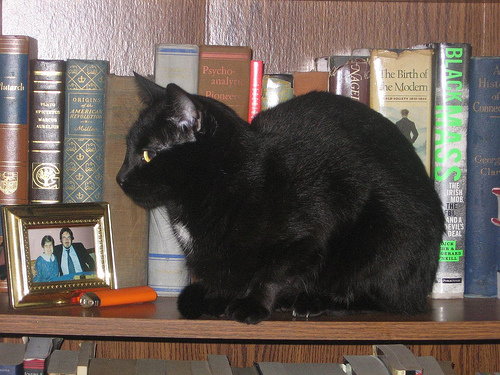<image>
Is there a orange lighter to the left of the black kitty? Yes. From this viewpoint, the orange lighter is positioned to the left side relative to the black kitty. 